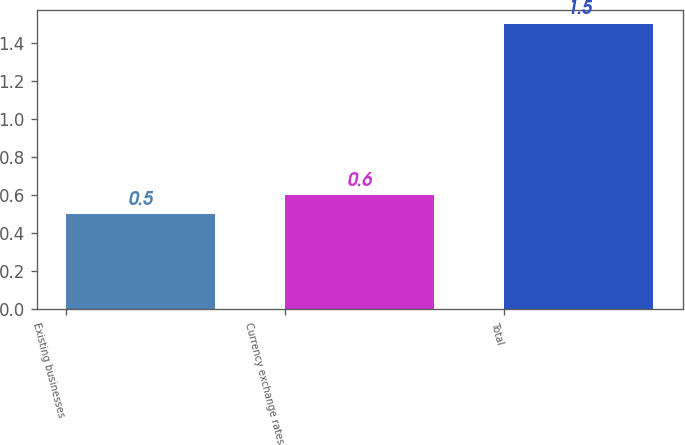<chart> <loc_0><loc_0><loc_500><loc_500><bar_chart><fcel>Existing businesses<fcel>Currency exchange rates<fcel>Total<nl><fcel>0.5<fcel>0.6<fcel>1.5<nl></chart> 